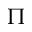<formula> <loc_0><loc_0><loc_500><loc_500>\Pi</formula> 